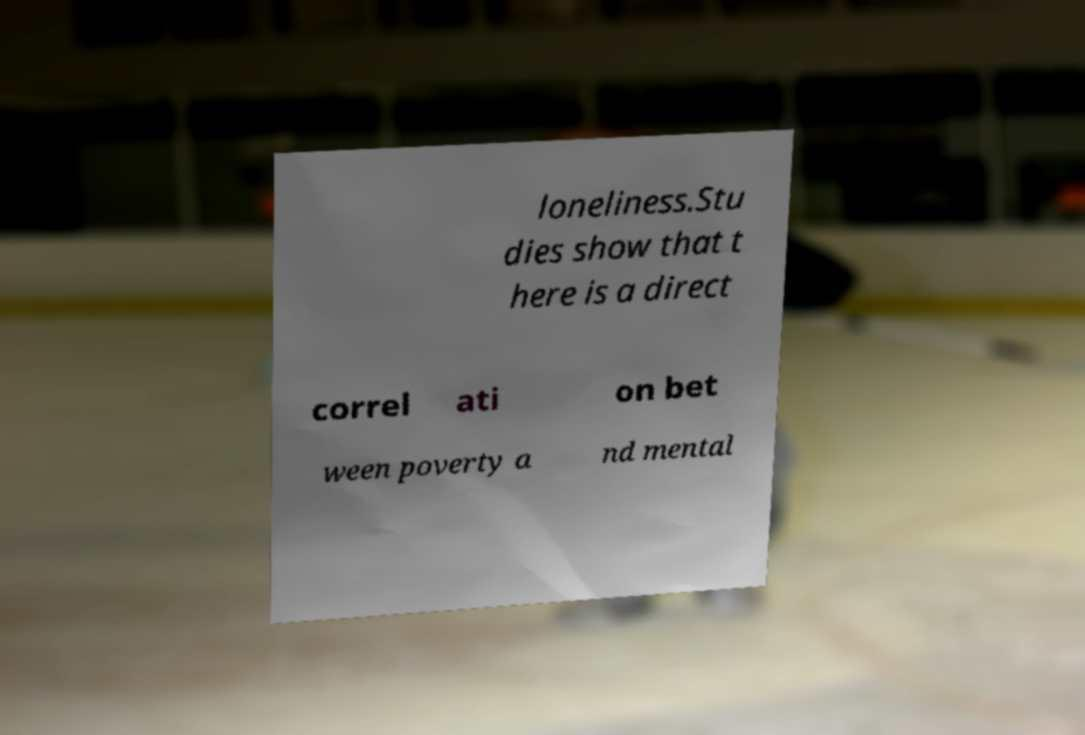Could you assist in decoding the text presented in this image and type it out clearly? loneliness.Stu dies show that t here is a direct correl ati on bet ween poverty a nd mental 